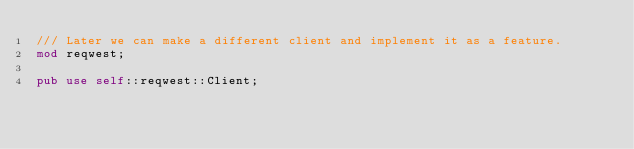Convert code to text. <code><loc_0><loc_0><loc_500><loc_500><_Rust_>/// Later we can make a different client and implement it as a feature.
mod reqwest;

pub use self::reqwest::Client;
</code> 